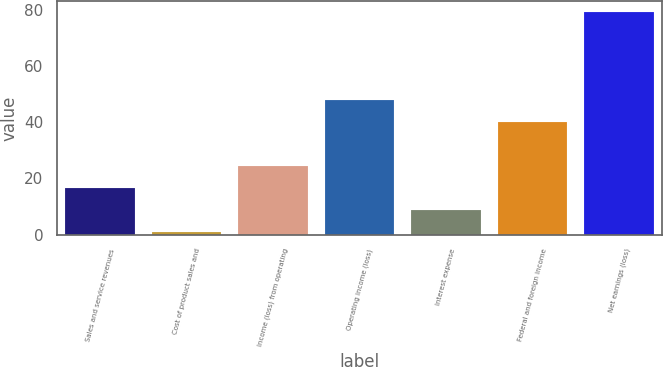Convert chart. <chart><loc_0><loc_0><loc_500><loc_500><bar_chart><fcel>Sales and service revenues<fcel>Cost of product sales and<fcel>Income (loss) from operating<fcel>Operating income (loss)<fcel>Interest expense<fcel>Federal and foreign income<fcel>Net earnings (loss)<nl><fcel>16.6<fcel>1<fcel>24.4<fcel>47.8<fcel>8.8<fcel>40<fcel>79<nl></chart> 